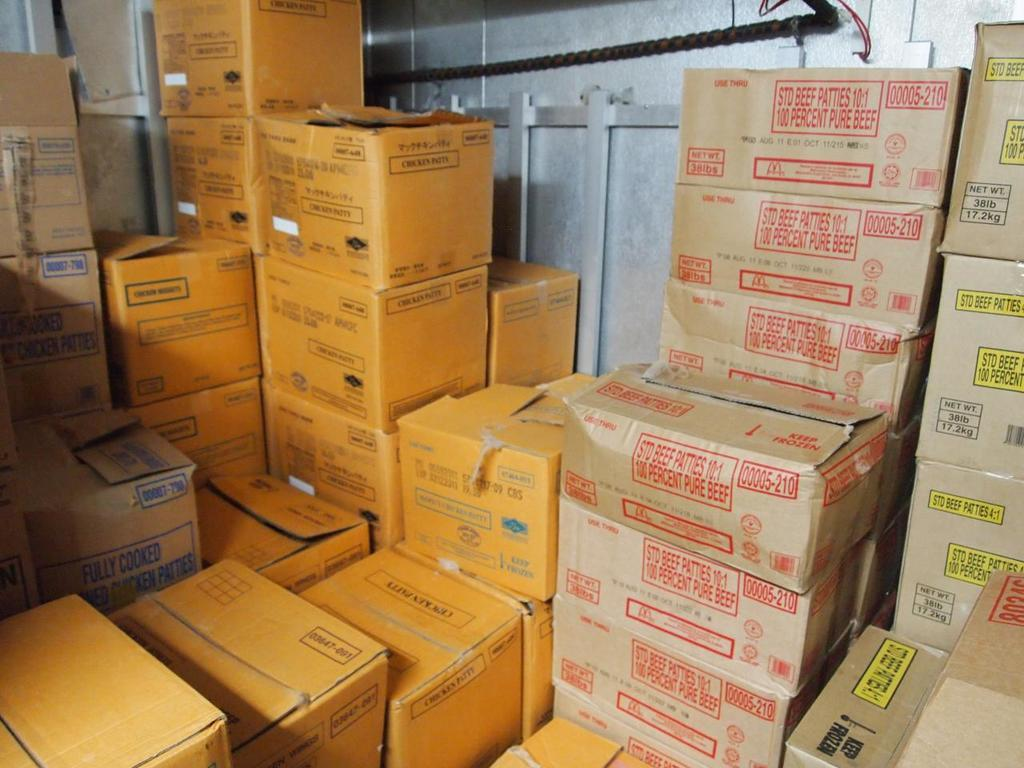Provide a one-sentence caption for the provided image. Boxes full of chicken patties and beef products. 